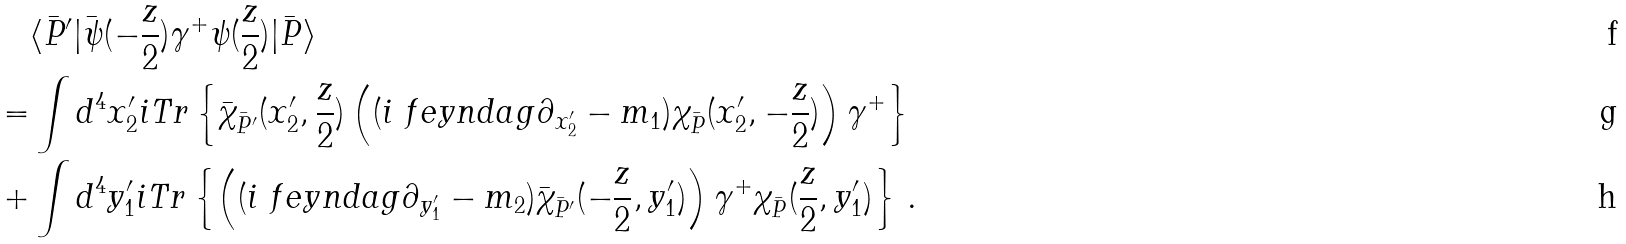Convert formula to latex. <formula><loc_0><loc_0><loc_500><loc_500>& \langle \bar { P } ^ { \prime } | \bar { \psi } ( - \frac { z } { 2 } ) \gamma ^ { + } \psi ( \frac { z } { 2 } ) | \bar { P } \rangle \\ = & \int d ^ { 4 } x _ { 2 } ^ { \prime } i T r \left \{ \bar { \chi } _ { \bar { P } ^ { \prime } } ( x _ { 2 } ^ { \prime } , \frac { z } { 2 } ) \left ( ( i \ f e y n d a g { \partial } _ { x _ { 2 } ^ { \prime } } - m _ { 1 } ) \chi _ { \bar { P } } ( x _ { 2 } ^ { \prime } , - \frac { z } { 2 } ) \right ) \gamma ^ { + } \right \} \\ + & \int d ^ { 4 } y _ { 1 } ^ { \prime } i T r \left \{ \left ( ( i \ f e y n d a g { \partial } _ { y _ { 1 } ^ { \prime } } - m _ { 2 } ) \bar { \chi } _ { \bar { P } ^ { \prime } } ( - \frac { z } { 2 } , y _ { 1 } ^ { \prime } ) \right ) \gamma ^ { + } \chi _ { \bar { P } } ( \frac { z } { 2 } , y _ { 1 } ^ { \prime } ) \right \} \, .</formula> 